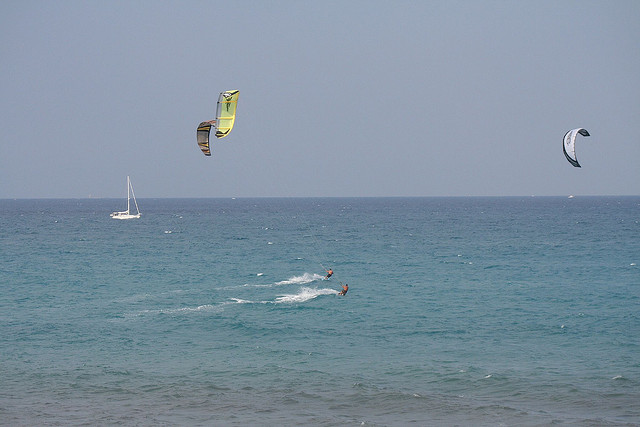Are there any boats or similar vessels in the image? Yes, there is a sailboat with a prominent mast visible in the image. 